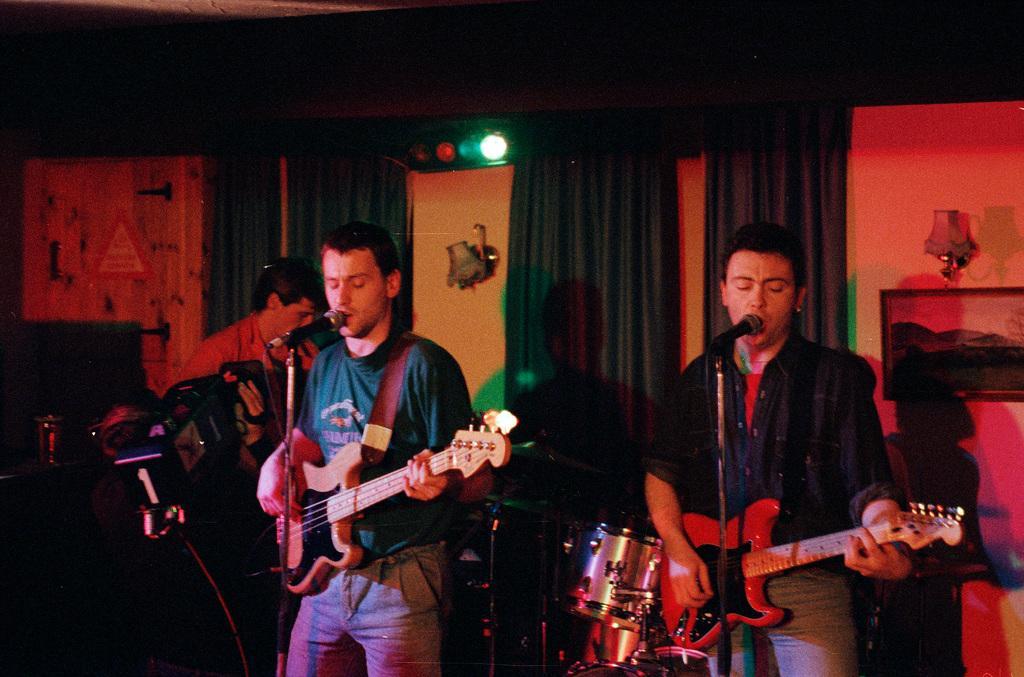In one or two sentences, can you explain what this image depicts? There are two persons standing. They are singing song and playing guitars. Here is the other man standing. These are the drums. At background I can see curtains hanging. This is the photo frame attached to the wall. These are the lamps attached to the wall. 